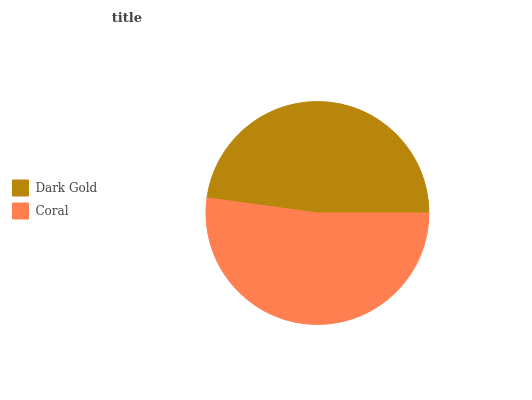Is Dark Gold the minimum?
Answer yes or no. Yes. Is Coral the maximum?
Answer yes or no. Yes. Is Coral the minimum?
Answer yes or no. No. Is Coral greater than Dark Gold?
Answer yes or no. Yes. Is Dark Gold less than Coral?
Answer yes or no. Yes. Is Dark Gold greater than Coral?
Answer yes or no. No. Is Coral less than Dark Gold?
Answer yes or no. No. Is Coral the high median?
Answer yes or no. Yes. Is Dark Gold the low median?
Answer yes or no. Yes. Is Dark Gold the high median?
Answer yes or no. No. Is Coral the low median?
Answer yes or no. No. 